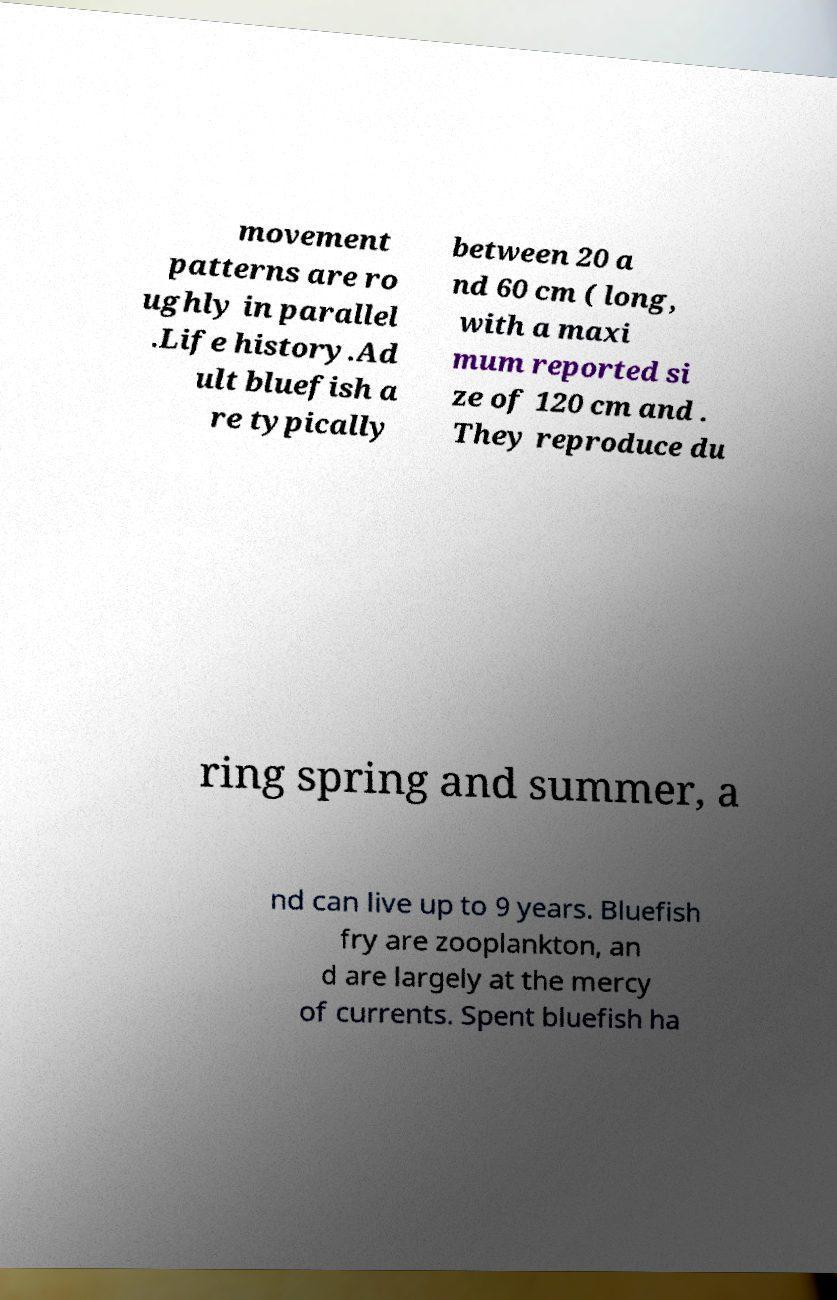Please read and relay the text visible in this image. What does it say? movement patterns are ro ughly in parallel .Life history.Ad ult bluefish a re typically between 20 a nd 60 cm ( long, with a maxi mum reported si ze of 120 cm and . They reproduce du ring spring and summer, a nd can live up to 9 years. Bluefish fry are zooplankton, an d are largely at the mercy of currents. Spent bluefish ha 